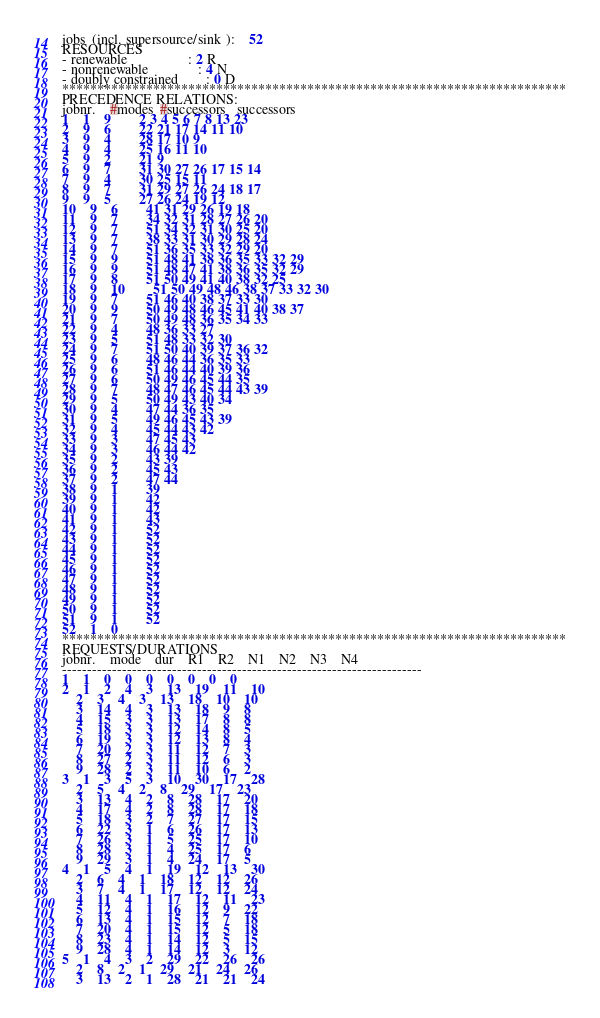<code> <loc_0><loc_0><loc_500><loc_500><_ObjectiveC_>jobs  (incl. supersource/sink ):	52
RESOURCES
- renewable                 : 2 R
- nonrenewable              : 4 N
- doubly constrained        : 0 D
************************************************************************
PRECEDENCE RELATIONS:
jobnr.    #modes  #successors   successors
1	1	9		2 3 4 5 6 7 8 13 23 
2	9	6		22 21 17 14 11 10 
3	9	4		28 17 10 9 
4	9	4		25 16 11 10 
5	9	2		21 9 
6	9	7		31 30 27 26 17 15 14 
7	9	4		30 25 15 11 
8	9	7		31 29 27 26 24 18 17 
9	9	5		27 26 24 19 12 
10	9	6		41 31 29 26 19 18 
11	9	7		34 32 31 28 27 26 20 
12	9	7		51 34 32 31 30 25 20 
13	9	7		38 33 31 30 29 28 24 
14	9	7		51 36 35 33 32 29 20 
15	9	9		51 48 41 38 36 35 33 32 29 
16	9	9		51 48 47 41 38 36 35 32 29 
17	9	8		51 50 49 41 40 38 32 25 
18	9	10		51 50 49 48 46 38 37 33 32 30 
19	9	7		51 46 40 38 37 33 30 
20	9	9		50 49 48 46 45 41 40 38 37 
21	9	7		50 49 48 36 35 34 33 
22	9	4		48 36 33 27 
23	9	5		51 48 33 32 30 
24	9	7		51 50 40 39 37 36 32 
25	9	6		48 46 44 36 35 33 
26	9	6		51 46 44 40 39 36 
27	9	6		50 49 46 45 44 35 
28	9	7		48 47 46 45 44 43 39 
29	9	5		50 49 43 40 34 
30	9	4		47 44 36 35 
31	9	5		49 46 45 43 39 
32	9	4		45 44 43 42 
33	9	3		47 45 43 
34	9	3		46 44 42 
35	9	2		43 39 
36	9	2		45 43 
37	9	2		47 44 
38	9	1		39 
39	9	1		42 
40	9	1		42 
41	9	1		43 
42	9	1		52 
43	9	1		52 
44	9	1		52 
45	9	1		52 
46	9	1		52 
47	9	1		52 
48	9	1		52 
49	9	1		52 
50	9	1		52 
51	9	1		52 
52	1	0		
************************************************************************
REQUESTS/DURATIONS
jobnr.	mode	dur	R1	R2	N1	N2	N3	N4	
------------------------------------------------------------------------
1	1	0	0	0	0	0	0	0	
2	1	2	4	3	13	19	11	10	
	2	3	4	3	13	18	10	10	
	3	14	4	3	13	18	9	8	
	4	15	3	3	13	17	8	8	
	5	18	3	3	12	14	8	5	
	6	19	3	3	12	13	8	4	
	7	20	2	3	11	12	7	3	
	8	27	2	3	11	12	6	3	
	9	28	2	3	11	10	6	2	
3	1	3	5	3	10	30	17	28	
	2	5	4	2	8	29	17	23	
	3	13	4	2	8	28	17	20	
	4	17	4	2	8	28	17	18	
	5	18	3	2	7	27	17	15	
	6	22	3	1	6	26	17	13	
	7	26	3	1	5	25	17	10	
	8	28	3	1	4	25	17	6	
	9	29	3	1	4	24	17	5	
4	1	5	4	1	19	12	13	30	
	2	6	4	1	18	12	12	26	
	3	7	4	1	17	12	12	24	
	4	11	4	1	17	12	11	23	
	5	12	4	1	16	12	9	22	
	6	13	4	1	15	12	7	18	
	7	20	4	1	15	12	5	18	
	8	23	4	1	14	12	5	15	
	9	28	4	1	14	12	3	12	
5	1	4	3	2	29	22	26	26	
	2	8	2	1	29	21	24	26	
	3	13	2	1	28	21	21	24	</code> 